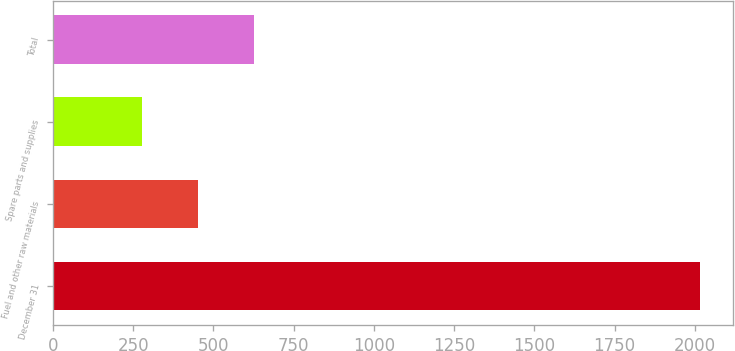Convert chart to OTSL. <chart><loc_0><loc_0><loc_500><loc_500><bar_chart><fcel>December 31<fcel>Fuel and other raw materials<fcel>Spare parts and supplies<fcel>Total<nl><fcel>2017<fcel>451.9<fcel>278<fcel>625.8<nl></chart> 